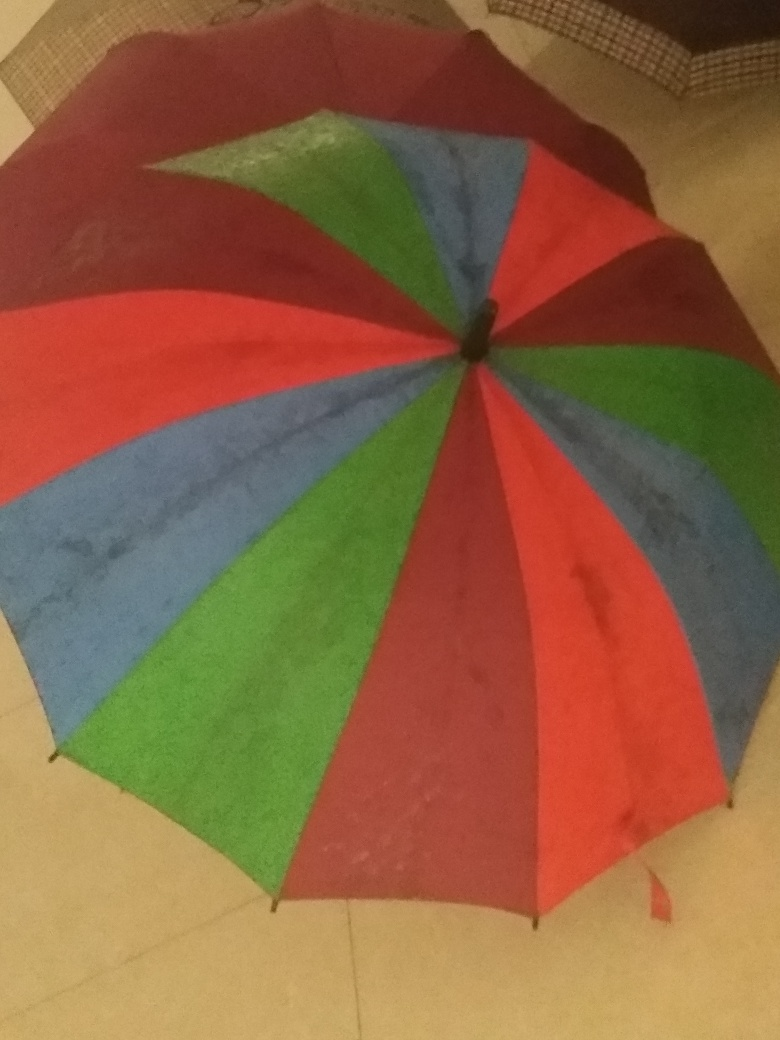Why is the umbrella on the ground? I can speculate a few reasons: it could be drying after use, it might have been placed there momentarily, or it has been discarded due to damage, though I don't see any obvious signs of the latter.  What does the setting tell us about where the umbrella might be? While the surroundings are mostly obscured, the presence of what appears to be indoor tile flooring suggests the umbrella is inside a building, possibly a residential or public space where someone has taken it off due to entering from the rain. 